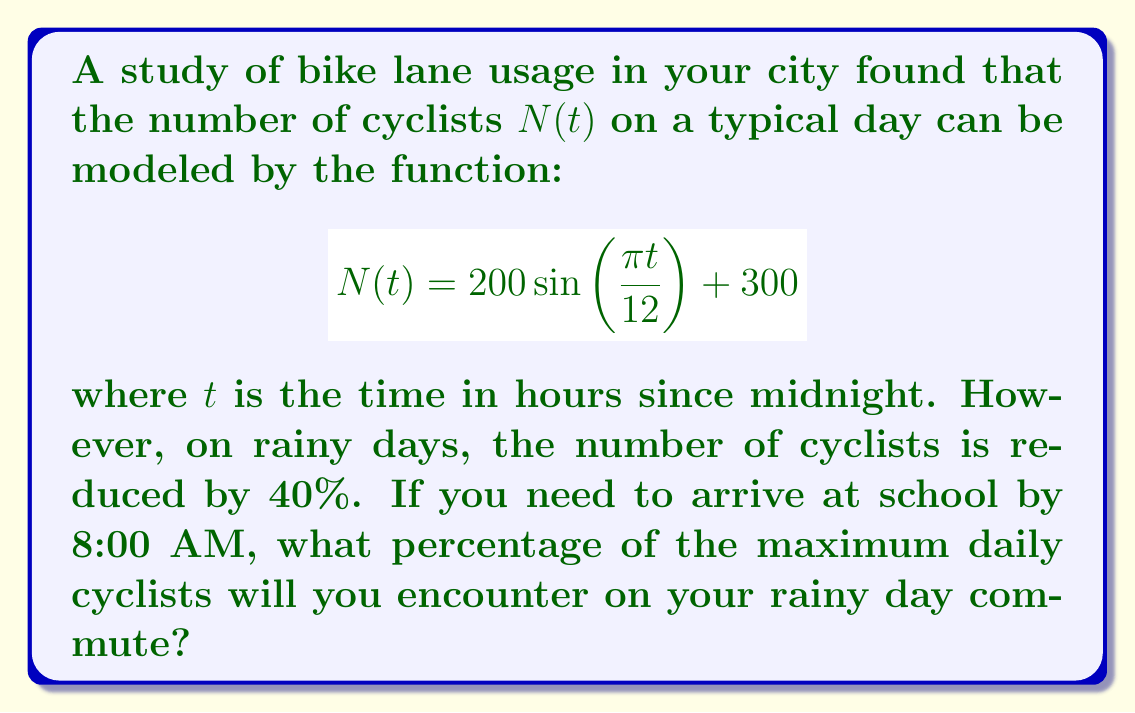Provide a solution to this math problem. 1. First, let's find the time $t$ corresponding to 8:00 AM:
   8:00 AM is 8 hours after midnight, so $t = 8$.

2. Now, let's calculate the number of cyclists at 8:00 AM on a typical day:
   $$N(8) = 200 \sin\left(\frac{\pi \cdot 8}{12}\right) + 300$$
   $$= 200 \sin\left(\frac{2\pi}{3}\right) + 300$$
   $$\approx 473.2$$

3. On a rainy day, this number is reduced by 40%:
   $$N_{rainy}(8) = 473.2 \cdot (1 - 0.4) = 283.92$$

4. To find the maximum daily cyclists, we need to find the maximum value of $N(t)$:
   The maximum occurs when $\sin\left(\frac{\pi t}{12}\right) = 1$
   $$N_{max} = 200 \cdot 1 + 300 = 500$$

5. Calculate the percentage of maximum cyclists encountered:
   $$\text{Percentage} = \frac{N_{rainy}(8)}{N_{max}} \cdot 100\%$$
   $$= \frac{283.92}{500} \cdot 100\% \approx 56.78\%$$
Answer: 56.78% 